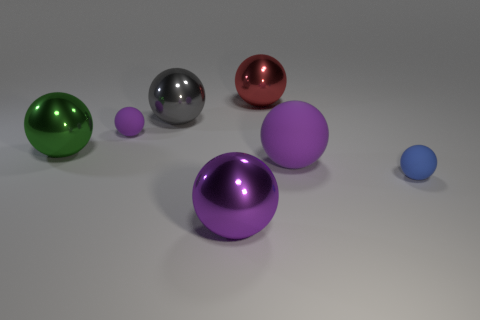Subtract all yellow blocks. How many purple spheres are left? 3 Subtract all big gray metallic balls. How many balls are left? 6 Subtract all green spheres. How many spheres are left? 6 Add 3 small purple balls. How many objects exist? 10 Subtract all yellow spheres. Subtract all cyan cylinders. How many spheres are left? 7 Subtract 0 red cubes. How many objects are left? 7 Subtract all large gray spheres. Subtract all green shiny things. How many objects are left? 5 Add 7 tiny balls. How many tiny balls are left? 9 Add 4 purple matte spheres. How many purple matte spheres exist? 6 